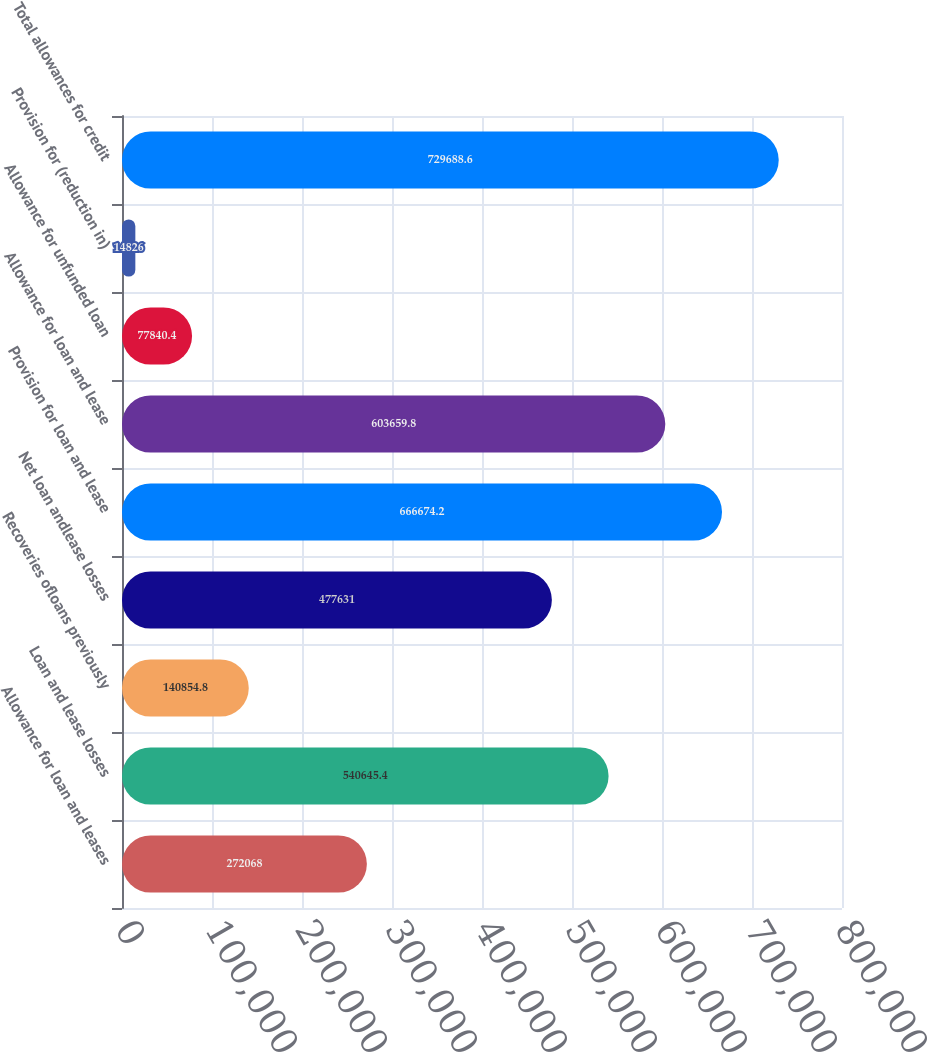<chart> <loc_0><loc_0><loc_500><loc_500><bar_chart><fcel>Allowance for loan and leases<fcel>Loan and lease losses<fcel>Recoveries ofloans previously<fcel>Net loan andlease losses<fcel>Provision for loan and lease<fcel>Allowance for loan and lease<fcel>Allowance for unfunded loan<fcel>Provision for (reduction in)<fcel>Total allowances for credit<nl><fcel>272068<fcel>540645<fcel>140855<fcel>477631<fcel>666674<fcel>603660<fcel>77840.4<fcel>14826<fcel>729689<nl></chart> 